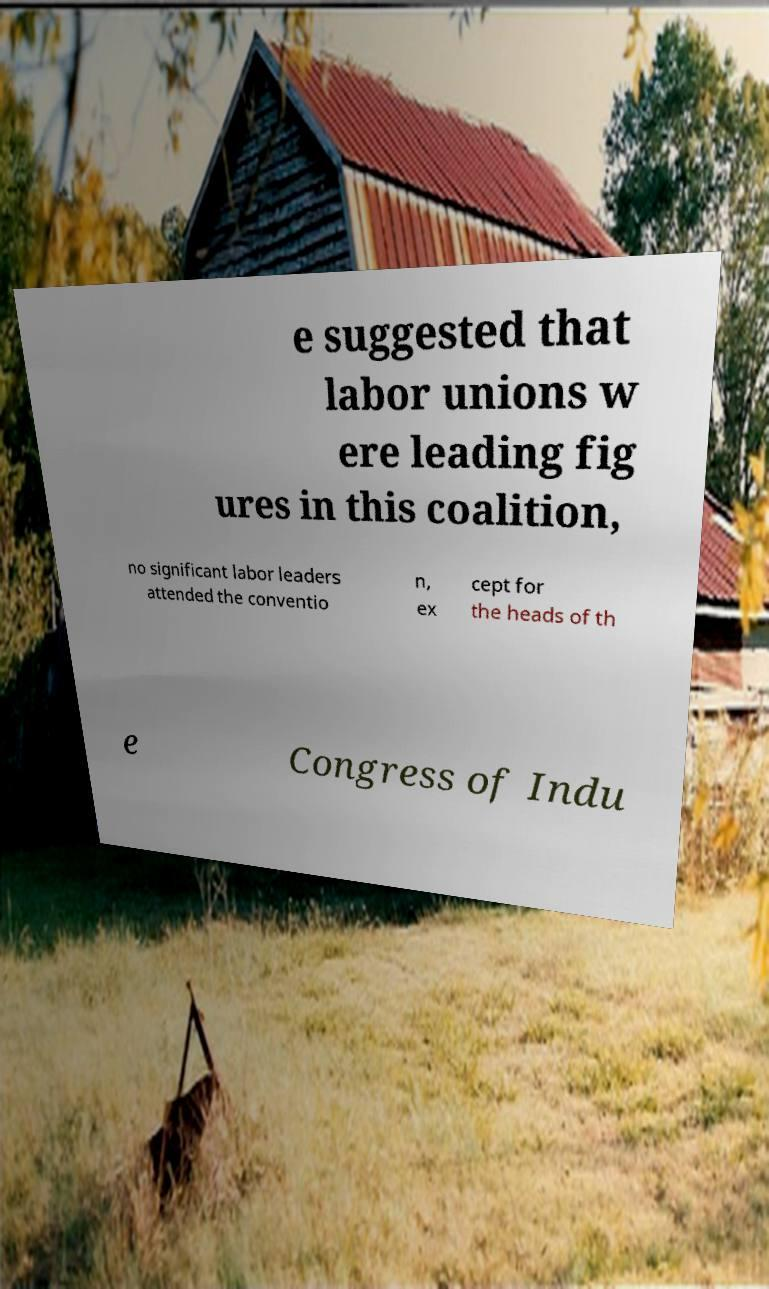Please identify and transcribe the text found in this image. e suggested that labor unions w ere leading fig ures in this coalition, no significant labor leaders attended the conventio n, ex cept for the heads of th e Congress of Indu 